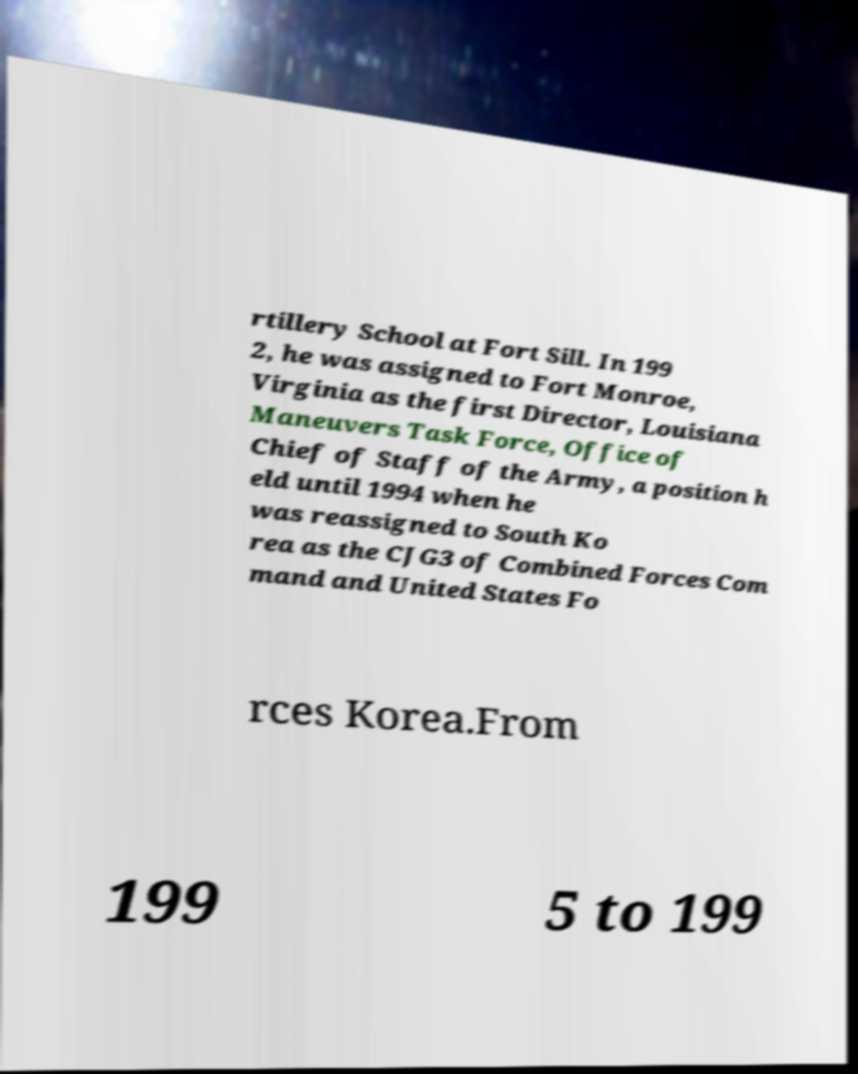Please identify and transcribe the text found in this image. rtillery School at Fort Sill. In 199 2, he was assigned to Fort Monroe, Virginia as the first Director, Louisiana Maneuvers Task Force, Office of Chief of Staff of the Army, a position h eld until 1994 when he was reassigned to South Ko rea as the CJG3 of Combined Forces Com mand and United States Fo rces Korea.From 199 5 to 199 